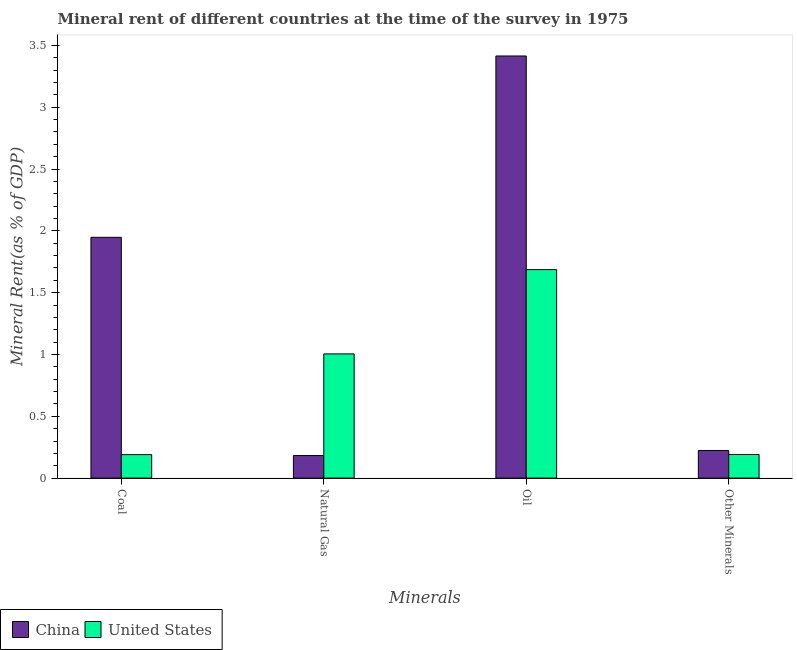Are the number of bars on each tick of the X-axis equal?
Your answer should be very brief. Yes. How many bars are there on the 2nd tick from the left?
Offer a terse response. 2. How many bars are there on the 4th tick from the right?
Your response must be concise. 2. What is the label of the 3rd group of bars from the left?
Your answer should be compact. Oil. What is the coal rent in United States?
Make the answer very short. 0.19. Across all countries, what is the maximum coal rent?
Provide a short and direct response. 1.95. Across all countries, what is the minimum  rent of other minerals?
Keep it short and to the point. 0.19. What is the total oil rent in the graph?
Your answer should be very brief. 5.1. What is the difference between the  rent of other minerals in United States and that in China?
Provide a succinct answer. -0.03. What is the difference between the coal rent in United States and the  rent of other minerals in China?
Your response must be concise. -0.03. What is the average coal rent per country?
Your response must be concise. 1.07. What is the difference between the  rent of other minerals and coal rent in United States?
Ensure brevity in your answer.  0. In how many countries, is the natural gas rent greater than 0.4 %?
Make the answer very short. 1. What is the ratio of the natural gas rent in United States to that in China?
Ensure brevity in your answer.  5.5. Is the coal rent in United States less than that in China?
Provide a succinct answer. Yes. What is the difference between the highest and the second highest  rent of other minerals?
Offer a very short reply. 0.03. What is the difference between the highest and the lowest natural gas rent?
Provide a short and direct response. 0.82. In how many countries, is the oil rent greater than the average oil rent taken over all countries?
Give a very brief answer. 1. Is the sum of the natural gas rent in United States and China greater than the maximum coal rent across all countries?
Your answer should be compact. No. What does the 2nd bar from the right in Natural Gas represents?
Ensure brevity in your answer.  China. Is it the case that in every country, the sum of the coal rent and natural gas rent is greater than the oil rent?
Provide a succinct answer. No. How many countries are there in the graph?
Your answer should be compact. 2. Where does the legend appear in the graph?
Offer a very short reply. Bottom left. How many legend labels are there?
Your answer should be compact. 2. What is the title of the graph?
Offer a terse response. Mineral rent of different countries at the time of the survey in 1975. Does "Myanmar" appear as one of the legend labels in the graph?
Offer a very short reply. No. What is the label or title of the X-axis?
Provide a succinct answer. Minerals. What is the label or title of the Y-axis?
Your response must be concise. Mineral Rent(as % of GDP). What is the Mineral Rent(as % of GDP) of China in Coal?
Offer a very short reply. 1.95. What is the Mineral Rent(as % of GDP) in United States in Coal?
Provide a succinct answer. 0.19. What is the Mineral Rent(as % of GDP) of China in Natural Gas?
Provide a succinct answer. 0.18. What is the Mineral Rent(as % of GDP) of United States in Natural Gas?
Provide a short and direct response. 1. What is the Mineral Rent(as % of GDP) of China in Oil?
Give a very brief answer. 3.41. What is the Mineral Rent(as % of GDP) in United States in Oil?
Offer a very short reply. 1.69. What is the Mineral Rent(as % of GDP) in China in Other Minerals?
Your response must be concise. 0.22. What is the Mineral Rent(as % of GDP) of United States in Other Minerals?
Keep it short and to the point. 0.19. Across all Minerals, what is the maximum Mineral Rent(as % of GDP) in China?
Ensure brevity in your answer.  3.41. Across all Minerals, what is the maximum Mineral Rent(as % of GDP) in United States?
Make the answer very short. 1.69. Across all Minerals, what is the minimum Mineral Rent(as % of GDP) of China?
Keep it short and to the point. 0.18. Across all Minerals, what is the minimum Mineral Rent(as % of GDP) of United States?
Keep it short and to the point. 0.19. What is the total Mineral Rent(as % of GDP) of China in the graph?
Give a very brief answer. 5.77. What is the total Mineral Rent(as % of GDP) of United States in the graph?
Make the answer very short. 3.07. What is the difference between the Mineral Rent(as % of GDP) in China in Coal and that in Natural Gas?
Make the answer very short. 1.76. What is the difference between the Mineral Rent(as % of GDP) in United States in Coal and that in Natural Gas?
Offer a terse response. -0.81. What is the difference between the Mineral Rent(as % of GDP) in China in Coal and that in Oil?
Offer a very short reply. -1.47. What is the difference between the Mineral Rent(as % of GDP) of United States in Coal and that in Oil?
Your answer should be very brief. -1.5. What is the difference between the Mineral Rent(as % of GDP) in China in Coal and that in Other Minerals?
Make the answer very short. 1.72. What is the difference between the Mineral Rent(as % of GDP) of United States in Coal and that in Other Minerals?
Give a very brief answer. -0. What is the difference between the Mineral Rent(as % of GDP) in China in Natural Gas and that in Oil?
Ensure brevity in your answer.  -3.23. What is the difference between the Mineral Rent(as % of GDP) in United States in Natural Gas and that in Oil?
Offer a very short reply. -0.68. What is the difference between the Mineral Rent(as % of GDP) in China in Natural Gas and that in Other Minerals?
Your answer should be compact. -0.04. What is the difference between the Mineral Rent(as % of GDP) in United States in Natural Gas and that in Other Minerals?
Keep it short and to the point. 0.81. What is the difference between the Mineral Rent(as % of GDP) of China in Oil and that in Other Minerals?
Your response must be concise. 3.19. What is the difference between the Mineral Rent(as % of GDP) of United States in Oil and that in Other Minerals?
Your answer should be very brief. 1.5. What is the difference between the Mineral Rent(as % of GDP) of China in Coal and the Mineral Rent(as % of GDP) of United States in Natural Gas?
Offer a terse response. 0.94. What is the difference between the Mineral Rent(as % of GDP) of China in Coal and the Mineral Rent(as % of GDP) of United States in Oil?
Offer a terse response. 0.26. What is the difference between the Mineral Rent(as % of GDP) of China in Coal and the Mineral Rent(as % of GDP) of United States in Other Minerals?
Your answer should be very brief. 1.76. What is the difference between the Mineral Rent(as % of GDP) of China in Natural Gas and the Mineral Rent(as % of GDP) of United States in Oil?
Your answer should be very brief. -1.5. What is the difference between the Mineral Rent(as % of GDP) in China in Natural Gas and the Mineral Rent(as % of GDP) in United States in Other Minerals?
Give a very brief answer. -0.01. What is the difference between the Mineral Rent(as % of GDP) of China in Oil and the Mineral Rent(as % of GDP) of United States in Other Minerals?
Provide a short and direct response. 3.22. What is the average Mineral Rent(as % of GDP) of China per Minerals?
Offer a very short reply. 1.44. What is the average Mineral Rent(as % of GDP) in United States per Minerals?
Your response must be concise. 0.77. What is the difference between the Mineral Rent(as % of GDP) in China and Mineral Rent(as % of GDP) in United States in Coal?
Your response must be concise. 1.76. What is the difference between the Mineral Rent(as % of GDP) of China and Mineral Rent(as % of GDP) of United States in Natural Gas?
Give a very brief answer. -0.82. What is the difference between the Mineral Rent(as % of GDP) in China and Mineral Rent(as % of GDP) in United States in Oil?
Provide a succinct answer. 1.73. What is the difference between the Mineral Rent(as % of GDP) in China and Mineral Rent(as % of GDP) in United States in Other Minerals?
Make the answer very short. 0.03. What is the ratio of the Mineral Rent(as % of GDP) in China in Coal to that in Natural Gas?
Offer a very short reply. 10.67. What is the ratio of the Mineral Rent(as % of GDP) of United States in Coal to that in Natural Gas?
Your answer should be very brief. 0.19. What is the ratio of the Mineral Rent(as % of GDP) in China in Coal to that in Oil?
Your answer should be compact. 0.57. What is the ratio of the Mineral Rent(as % of GDP) of United States in Coal to that in Oil?
Your answer should be compact. 0.11. What is the ratio of the Mineral Rent(as % of GDP) of China in Coal to that in Other Minerals?
Offer a very short reply. 8.71. What is the ratio of the Mineral Rent(as % of GDP) of China in Natural Gas to that in Oil?
Make the answer very short. 0.05. What is the ratio of the Mineral Rent(as % of GDP) in United States in Natural Gas to that in Oil?
Your answer should be compact. 0.6. What is the ratio of the Mineral Rent(as % of GDP) of China in Natural Gas to that in Other Minerals?
Keep it short and to the point. 0.82. What is the ratio of the Mineral Rent(as % of GDP) of United States in Natural Gas to that in Other Minerals?
Ensure brevity in your answer.  5.26. What is the ratio of the Mineral Rent(as % of GDP) in China in Oil to that in Other Minerals?
Your response must be concise. 15.27. What is the ratio of the Mineral Rent(as % of GDP) of United States in Oil to that in Other Minerals?
Provide a short and direct response. 8.82. What is the difference between the highest and the second highest Mineral Rent(as % of GDP) in China?
Ensure brevity in your answer.  1.47. What is the difference between the highest and the second highest Mineral Rent(as % of GDP) of United States?
Your answer should be compact. 0.68. What is the difference between the highest and the lowest Mineral Rent(as % of GDP) of China?
Offer a very short reply. 3.23. What is the difference between the highest and the lowest Mineral Rent(as % of GDP) of United States?
Provide a short and direct response. 1.5. 